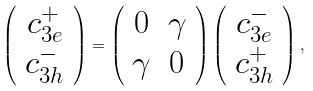<formula> <loc_0><loc_0><loc_500><loc_500>\left ( \begin{array} { c } c _ { 3 e } ^ { + } \\ c _ { 3 h } ^ { - } \end{array} \right ) = \left ( \begin{array} { c c } 0 & \gamma \\ \gamma & 0 \end{array} \right ) \left ( \begin{array} { c } c _ { 3 e } ^ { - } \\ c _ { 3 h } ^ { + } \end{array} \right ) ,</formula> 